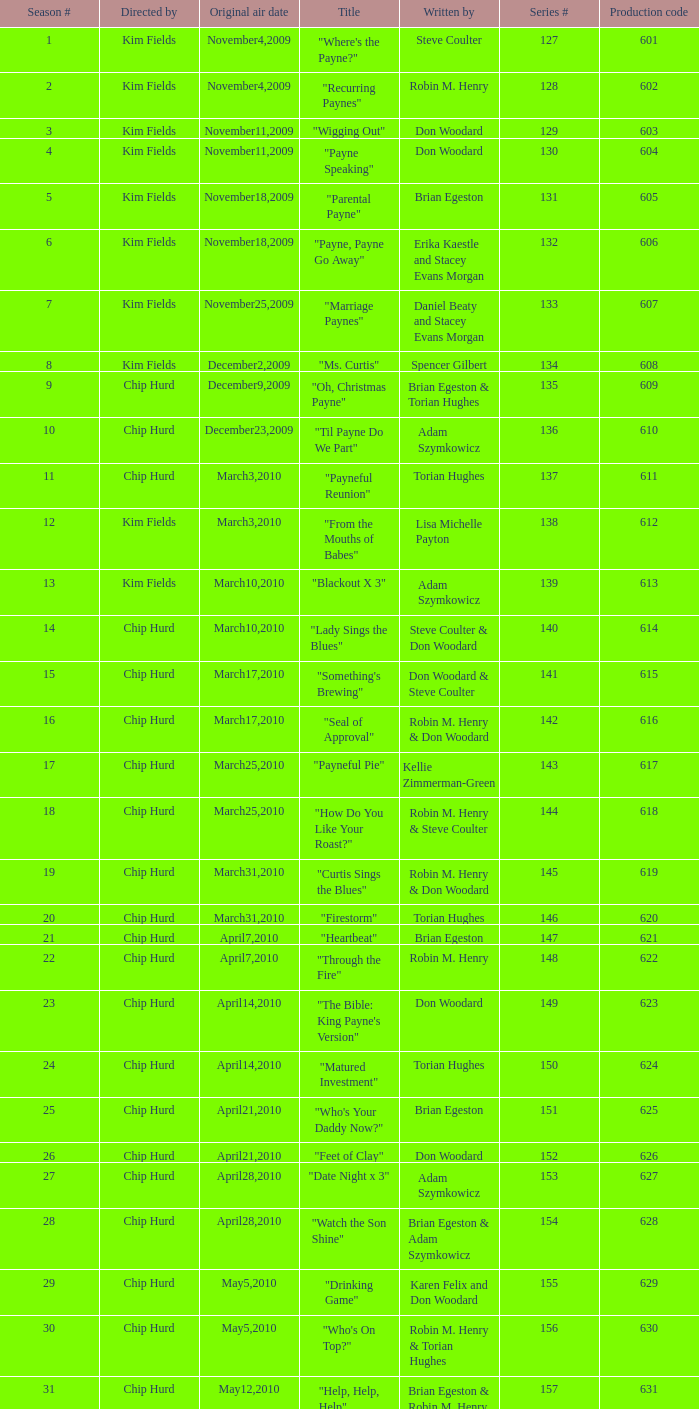What is the original air dates for the title "firestorm"? March31,2010. 